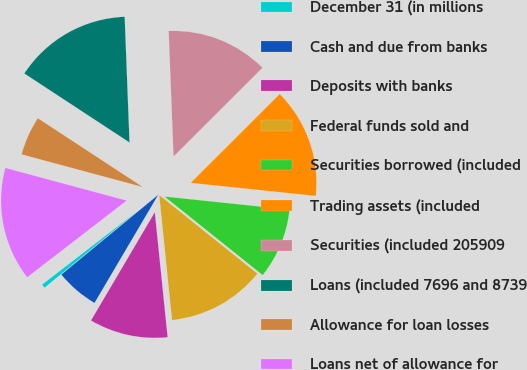Convert chart. <chart><loc_0><loc_0><loc_500><loc_500><pie_chart><fcel>December 31 (in millions<fcel>Cash and due from banks<fcel>Deposits with banks<fcel>Federal funds sold and<fcel>Securities borrowed (included<fcel>Trading assets (included<fcel>Securities (included 205909<fcel>Loans (included 7696 and 8739<fcel>Allowance for loan losses<fcel>Loans net of allowance for<nl><fcel>0.51%<fcel>5.56%<fcel>10.1%<fcel>12.63%<fcel>9.09%<fcel>14.14%<fcel>13.13%<fcel>15.15%<fcel>5.05%<fcel>14.64%<nl></chart> 